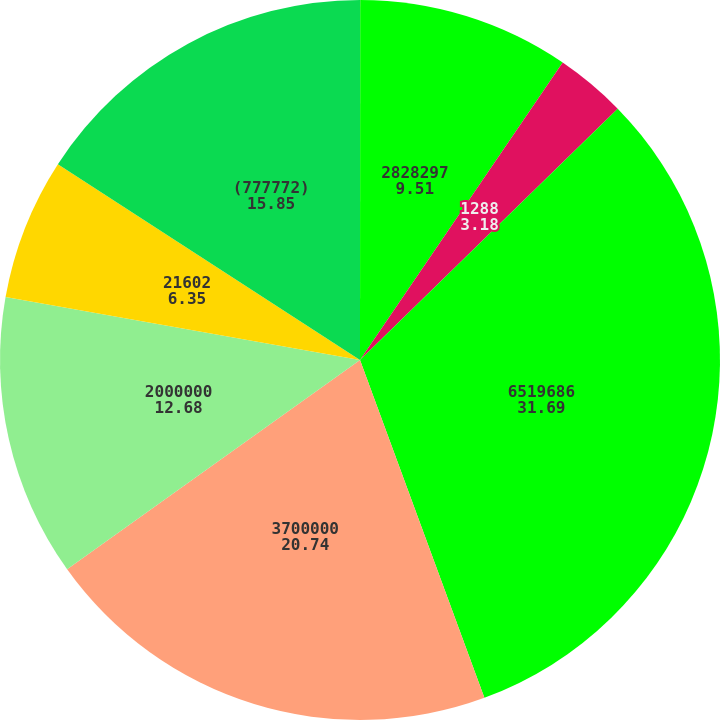Convert chart to OTSL. <chart><loc_0><loc_0><loc_500><loc_500><pie_chart><fcel>2001<fcel>2828297<fcel>1288<fcel>6519686<fcel>3700000<fcel>2000000<fcel>21602<fcel>(777772)<nl><fcel>0.01%<fcel>9.51%<fcel>3.18%<fcel>31.69%<fcel>20.74%<fcel>12.68%<fcel>6.35%<fcel>15.85%<nl></chart> 